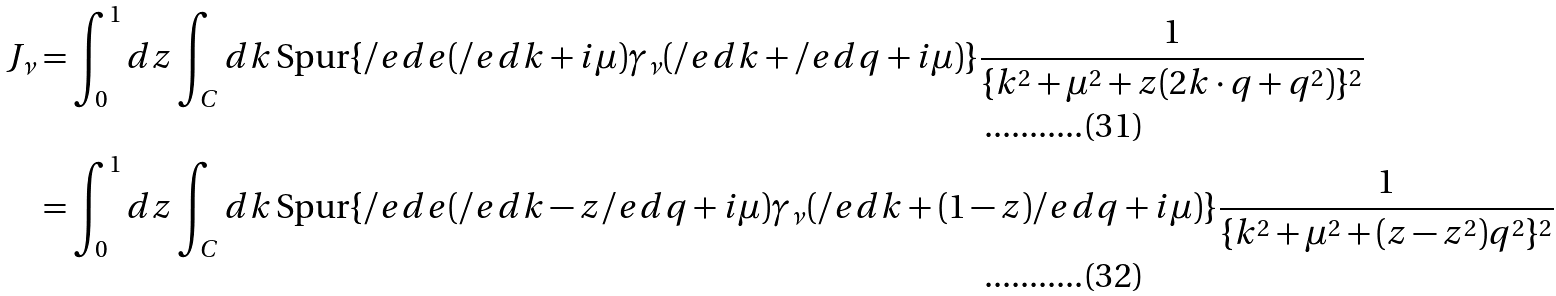Convert formula to latex. <formula><loc_0><loc_0><loc_500><loc_500>J _ { \nu } & = \int _ { 0 } ^ { 1 } d z \int _ { C } d k \, \text {Spur} \{ \slash e d { e } ( \slash e d { k } + i \mu ) \gamma _ { \nu } ( \slash e d { k } + \slash e d { q } + i \mu ) \} \frac { 1 } { \{ k ^ { 2 } + \mu ^ { 2 } + z ( 2 k \cdot q + q ^ { 2 } ) \} ^ { 2 } } \\ & = \int _ { 0 } ^ { 1 } d z \int _ { C } d k \, \text {Spur} \{ \slash e d { e } ( \slash e d { k } - z \slash e d { q } + i \mu ) \gamma _ { \nu } ( \slash e d { k } + ( 1 - z ) \slash e d { q } + i \mu ) \} \frac { 1 } { \{ k ^ { 2 } + \mu ^ { 2 } + ( z - z ^ { 2 } ) q ^ { 2 } \} ^ { 2 } }</formula> 